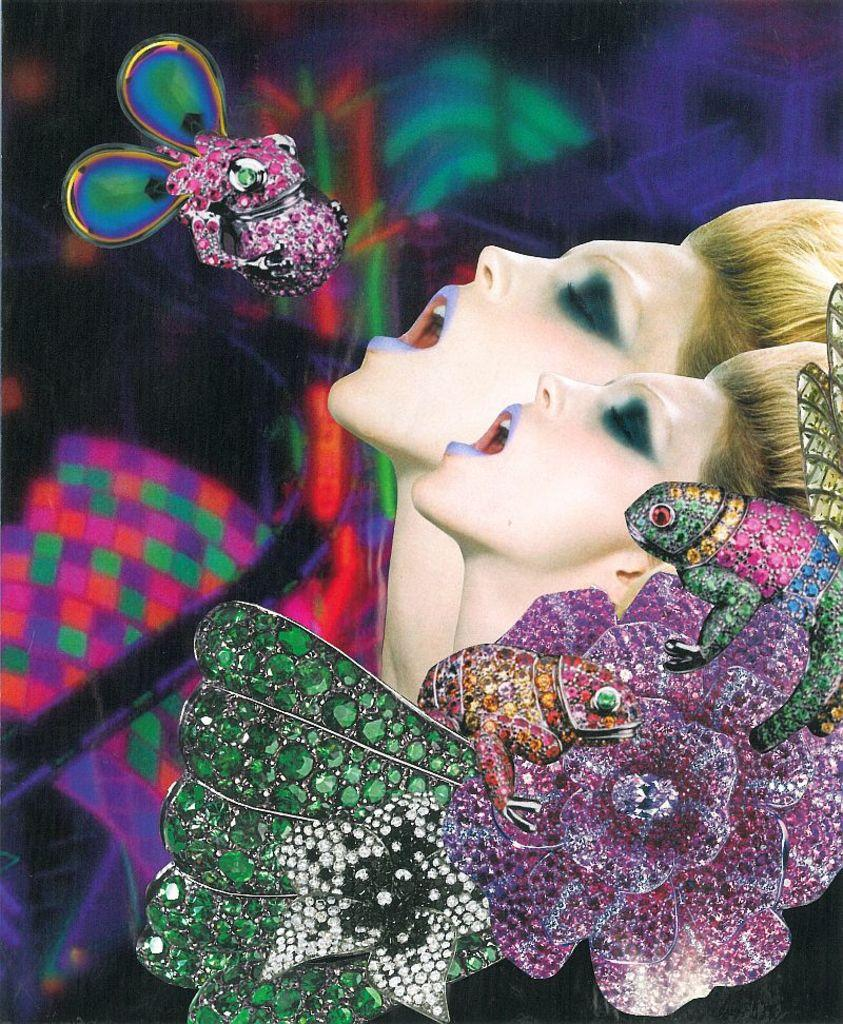How many women are in the image? There are 2 women in the image. Where are the women located in the image? The women are on the left side of the image. What can be seen in the image besides the women? There are flowers and animals in the image. What are the animals holding in the image? The animals have stones in the image. What is present on the left side of the image? There is an object on the left side of the image. How would you describe the background of the image? The background of the image is colorful. What is the average income of the women in the image? There is no information about the income of the women in the image. Is there a basketball court visible in the image? There is no basketball court present in the image. 